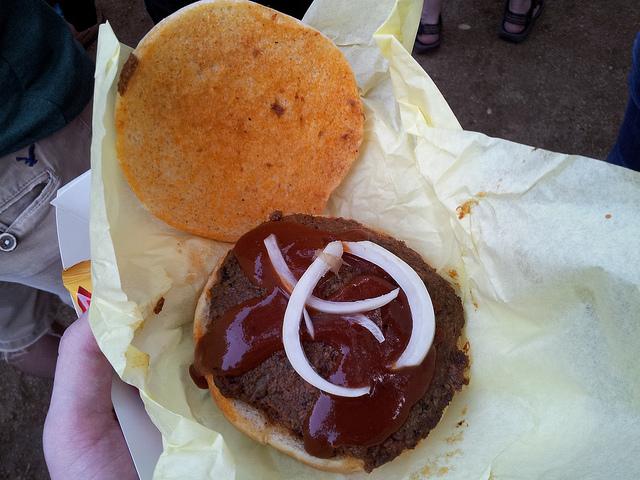Is that barbecue sauce on the burger?
Give a very brief answer. Yes. What kind of sandwich is this?
Keep it brief. Hamburger. What is on this sandwich?
Write a very short answer. Ketchup and onions. 